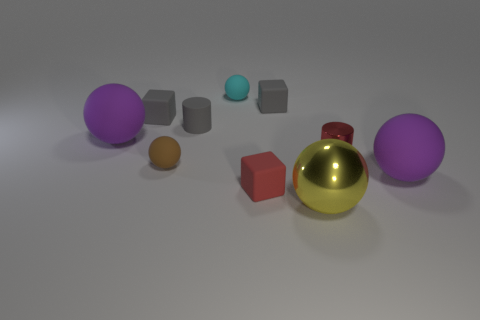There is a thing that is the same color as the shiny cylinder; what shape is it?
Offer a terse response. Cube. The purple object that is on the left side of the large matte ball in front of the red cylinder is made of what material?
Offer a terse response. Rubber. Is the tiny sphere behind the red cylinder made of the same material as the red cylinder?
Your response must be concise. No. There is a metallic thing behind the large metal object; how big is it?
Make the answer very short. Small. Are there any big yellow metal objects that are left of the purple rubber ball behind the small red shiny cylinder?
Your response must be concise. No. Is the color of the tiny matte block left of the matte cylinder the same as the tiny thing in front of the tiny brown matte sphere?
Your answer should be compact. No. The large shiny ball has what color?
Ensure brevity in your answer.  Yellow. Are there any other things that are the same color as the small shiny object?
Your answer should be very brief. Yes. What color is the rubber sphere that is both on the right side of the tiny rubber cylinder and in front of the small cyan matte ball?
Make the answer very short. Purple. Does the metal sphere on the left side of the red cylinder have the same size as the red rubber object?
Offer a very short reply. No. 